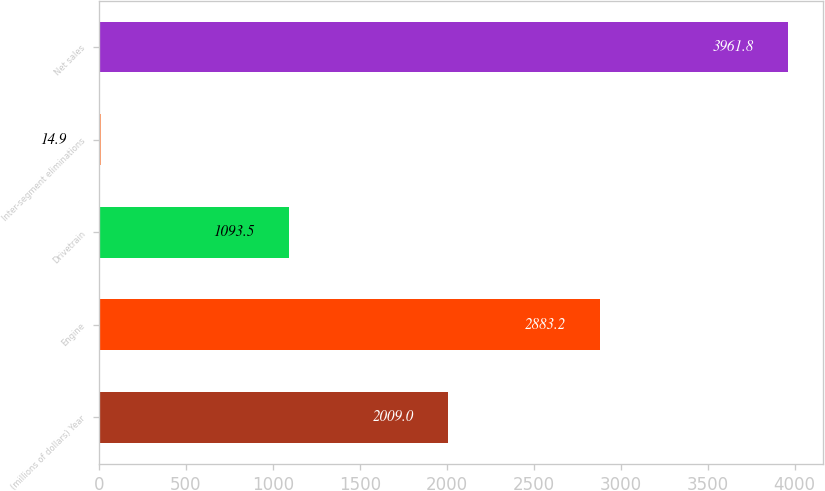Convert chart to OTSL. <chart><loc_0><loc_0><loc_500><loc_500><bar_chart><fcel>(millions of dollars) Year<fcel>Engine<fcel>Drivetrain<fcel>Inter-segment eliminations<fcel>Net sales<nl><fcel>2009<fcel>2883.2<fcel>1093.5<fcel>14.9<fcel>3961.8<nl></chart> 